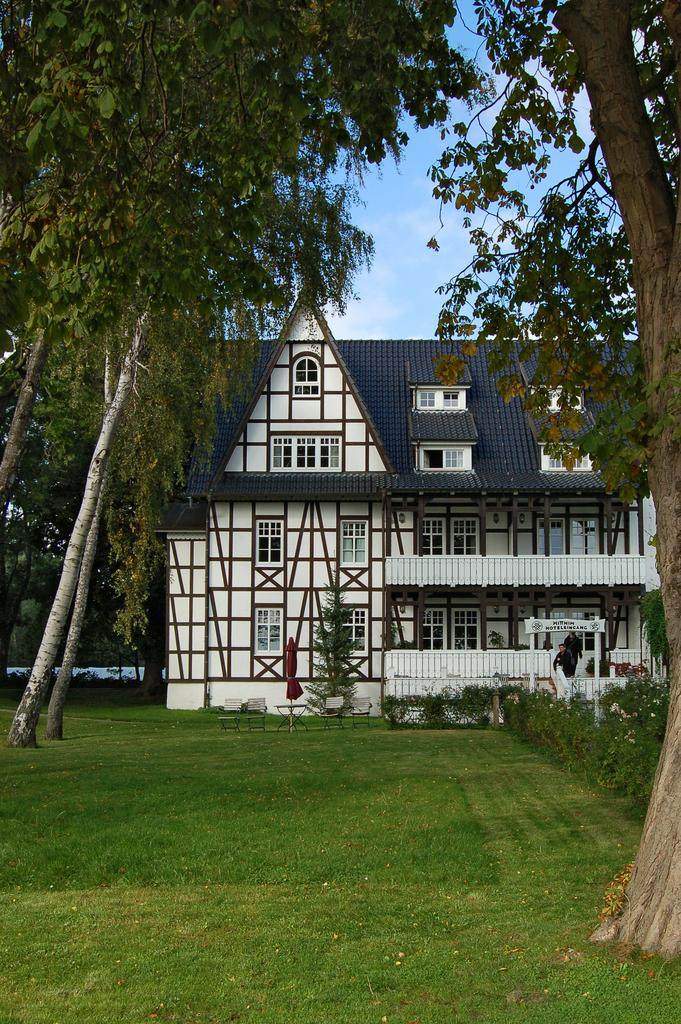What type of structure is present in the image? There is a building in the image. What other natural elements can be seen in the image? There are trees, plants, and grass visible in the image. What is the white object with writing in the image? There is a white color board with writing in the image. What is visible in the background of the image? The sky is visible in the background of the image. What is the manager's thought about the shocking event in the image? There is no manager or shocking event present in the image; it features a building, trees, plants, grass, a white color board, and the sky. 